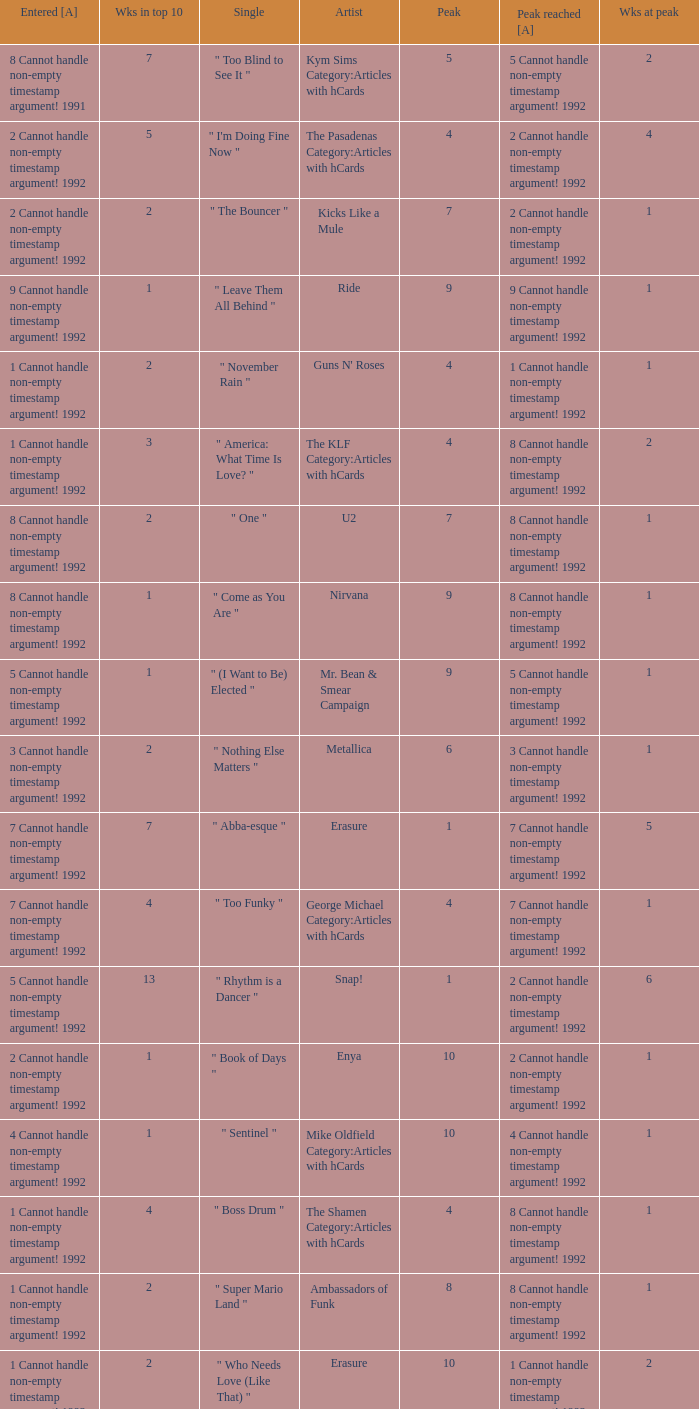If the peak reached is 6 cannot handle non-empty timestamp argument! 1992, what is the entered? 6 Cannot handle non-empty timestamp argument! 1992. 